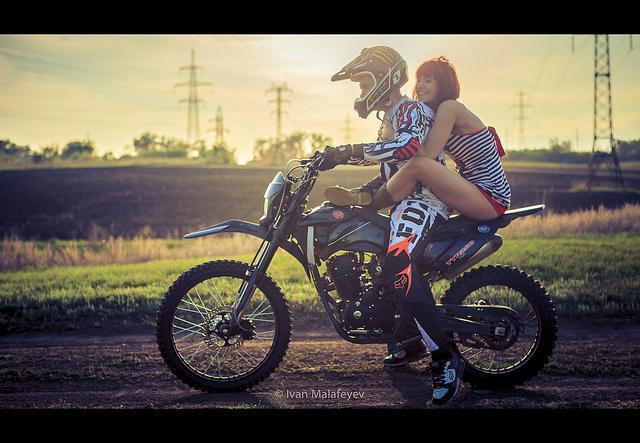How many people are in the picture?
Give a very brief answer. 2. 